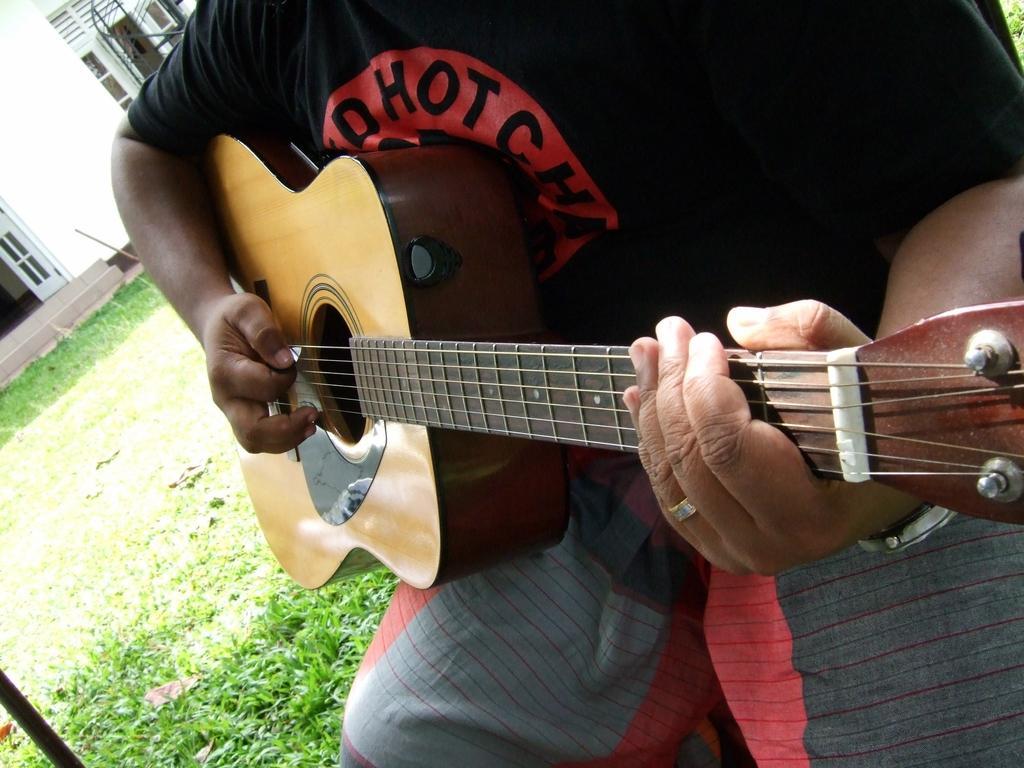Can you describe this image briefly? In this Image I see a person who is holding a guitar and I see the grass over here. 